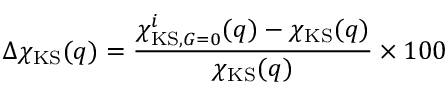<formula> <loc_0><loc_0><loc_500><loc_500>\Delta \chi _ { K S } ( q ) = \frac { \chi _ { K S , G = 0 } ^ { i } ( q ) - \chi _ { K S } ( q ) } { \chi _ { K S } ( q ) } \times 1 0 0 \</formula> 